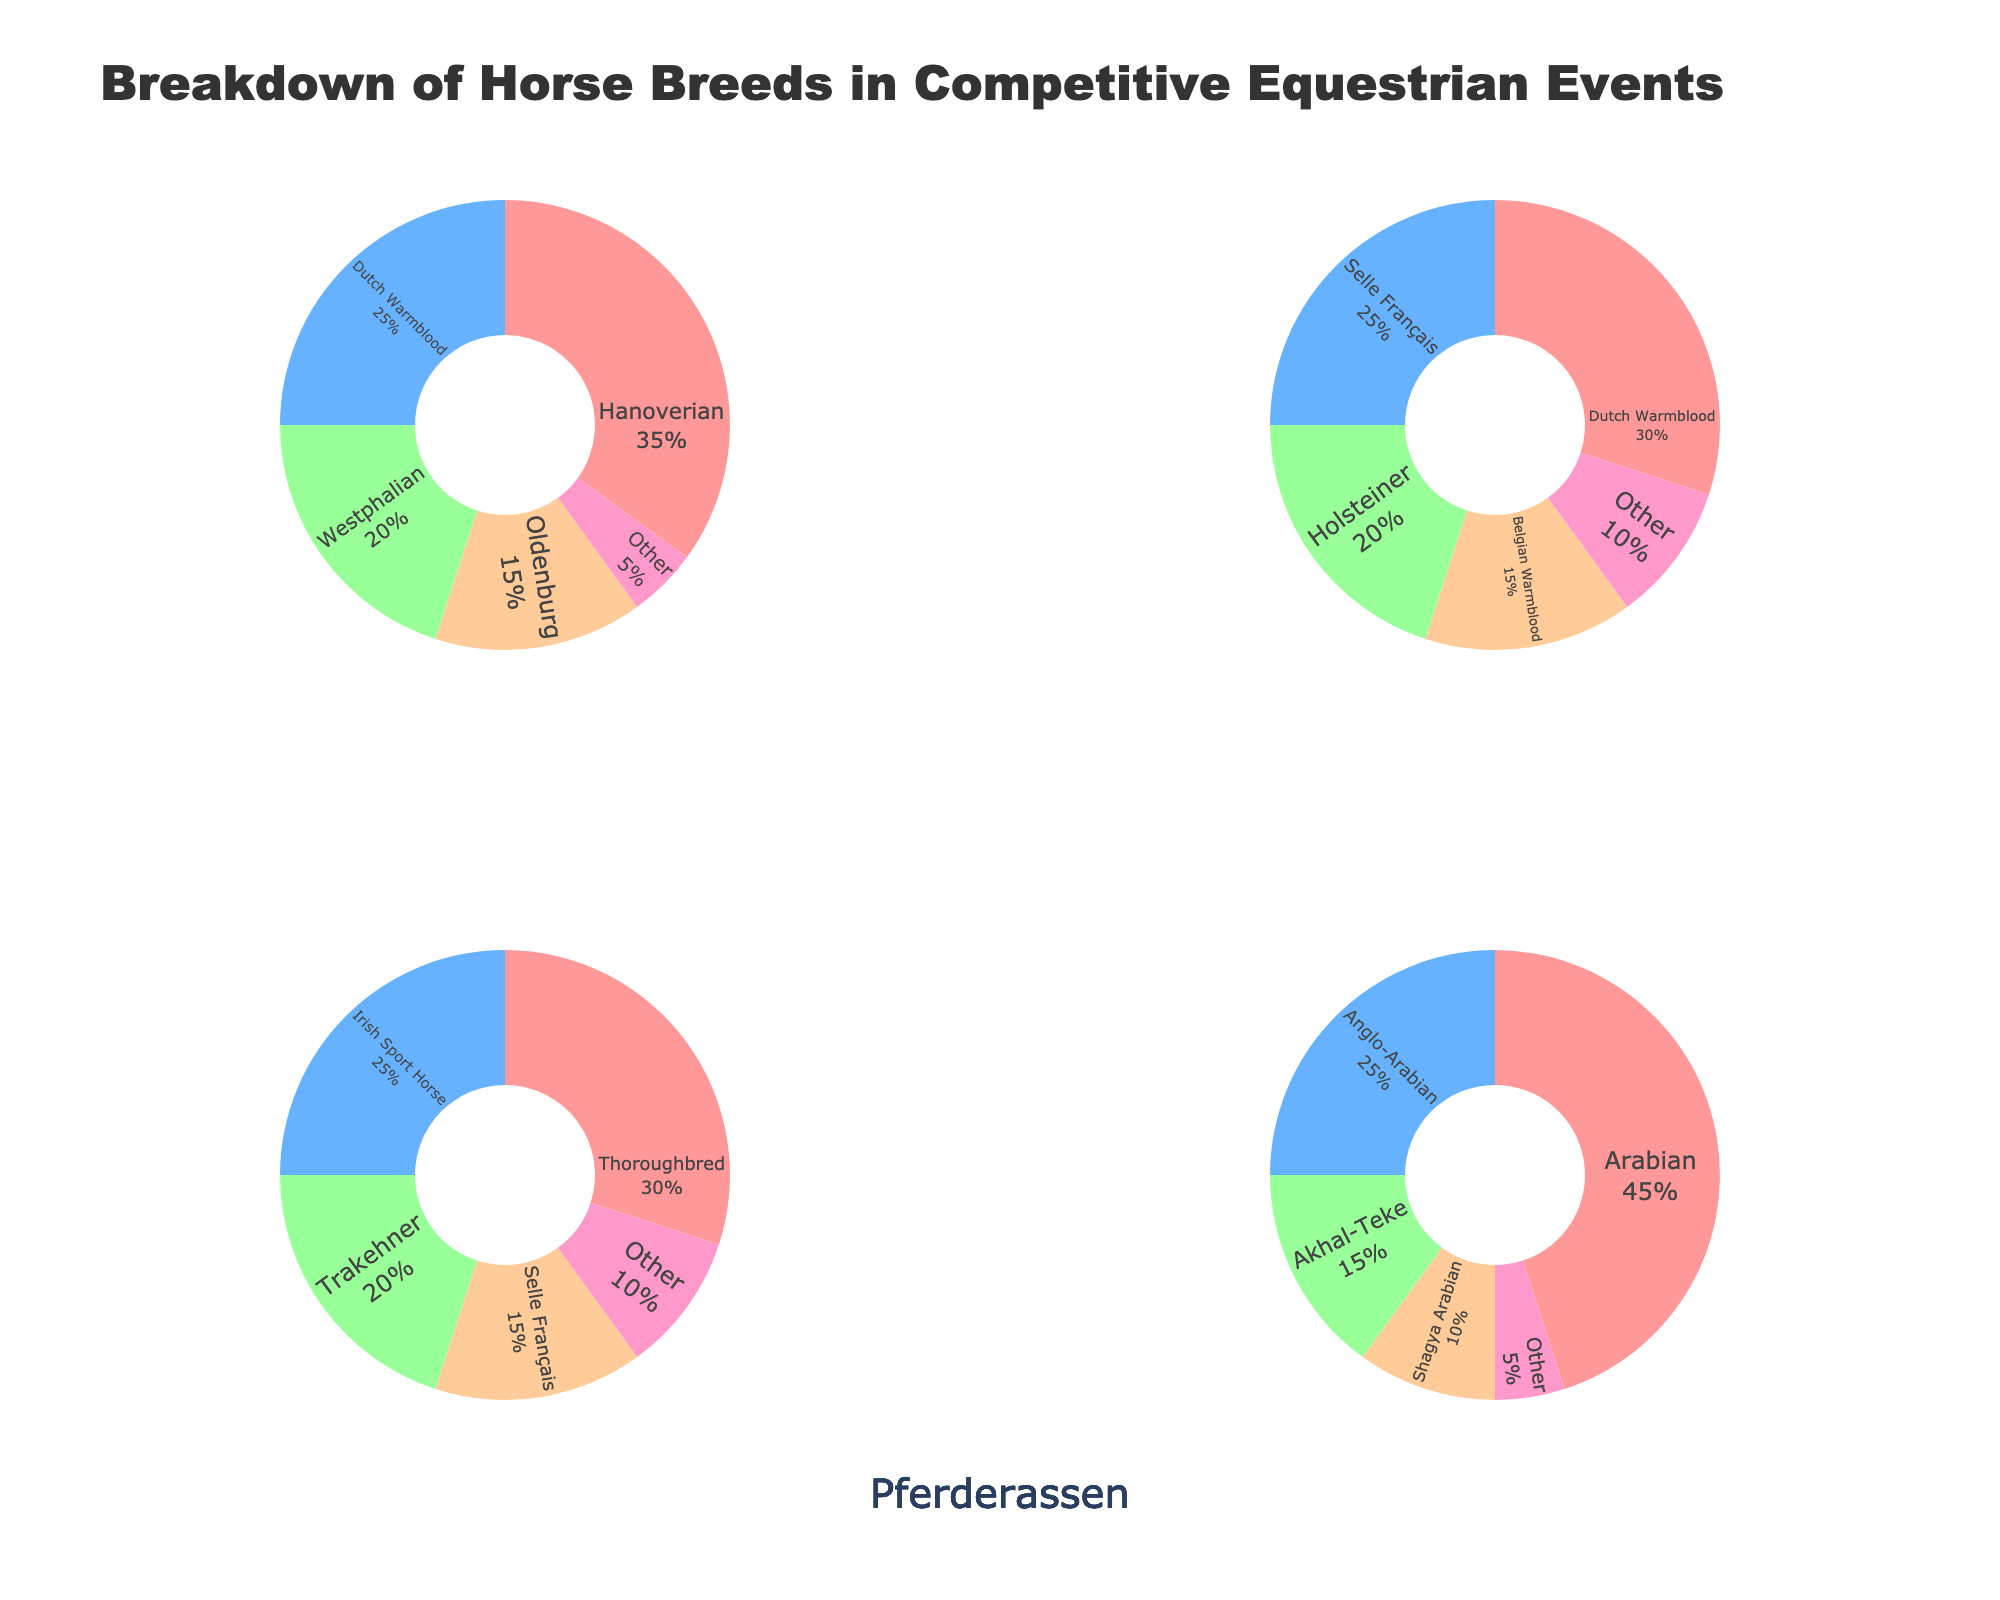What is the title of the figure? The title of the figure is usually placed prominently at the top. From the data, we see that the title set in the code is "Breakdown of Horse Breeds in Competitive Equestrian Events".
Answer: Breakdown of Horse Breeds in Competitive Equestrian Events Which event has the highest percentage of a single breed? We see that the Arabian breed in the Endurance event has the highest percentage at 45%.
Answer: Endurance What is the combined percentage of Hanoverian and Dutch Warmblood breeds in Dressage? From the Dressage pie chart, Hanoverian is 35% and Dutch Warmblood is 25%. Summing them: 35 + 25 = 60.
Answer: 60% Which breed is more commonly represented in Show Jumping: Selle Français or Holsteiner? From the Show Jumping pie chart, Selle Français is 25%, and Holsteiner is 20%. 25% is greater than 20%.
Answer: Selle Français What percentage of Eventing horses are Thoroughbreds? Directly from the Eventing pie chart, Thoroughbreds make up 30%.
Answer: 30% How does the percentage of Oldenburg in Dressage compare to the percentage of Belgian Warmblood in Show Jumping? Oldenburg in Dressage is 15%, and Belgian Warmblood in Show Jumping is 15%. They are equal.
Answer: They are equal What is the total percentage of 'Other' breeds across all events? Sum the 'Other' breed percentages: Dressage (5%) + Show Jumping (10%) + Eventing (10%) + Endurance (5%) = 30%.
Answer: 30% Which event has the smallest representation of its top breed? By examining each event, the smallest top breed is seen in Dressage (Hanoverian at 35%), compared to other top breeds having higher percentages.
Answer: Dressage Which breed appears in both Eventing and Show Jumping? From the two charts, Selle Français appears in both Eventing (15%) and Show Jumping (25%).
Answer: Selle Français 